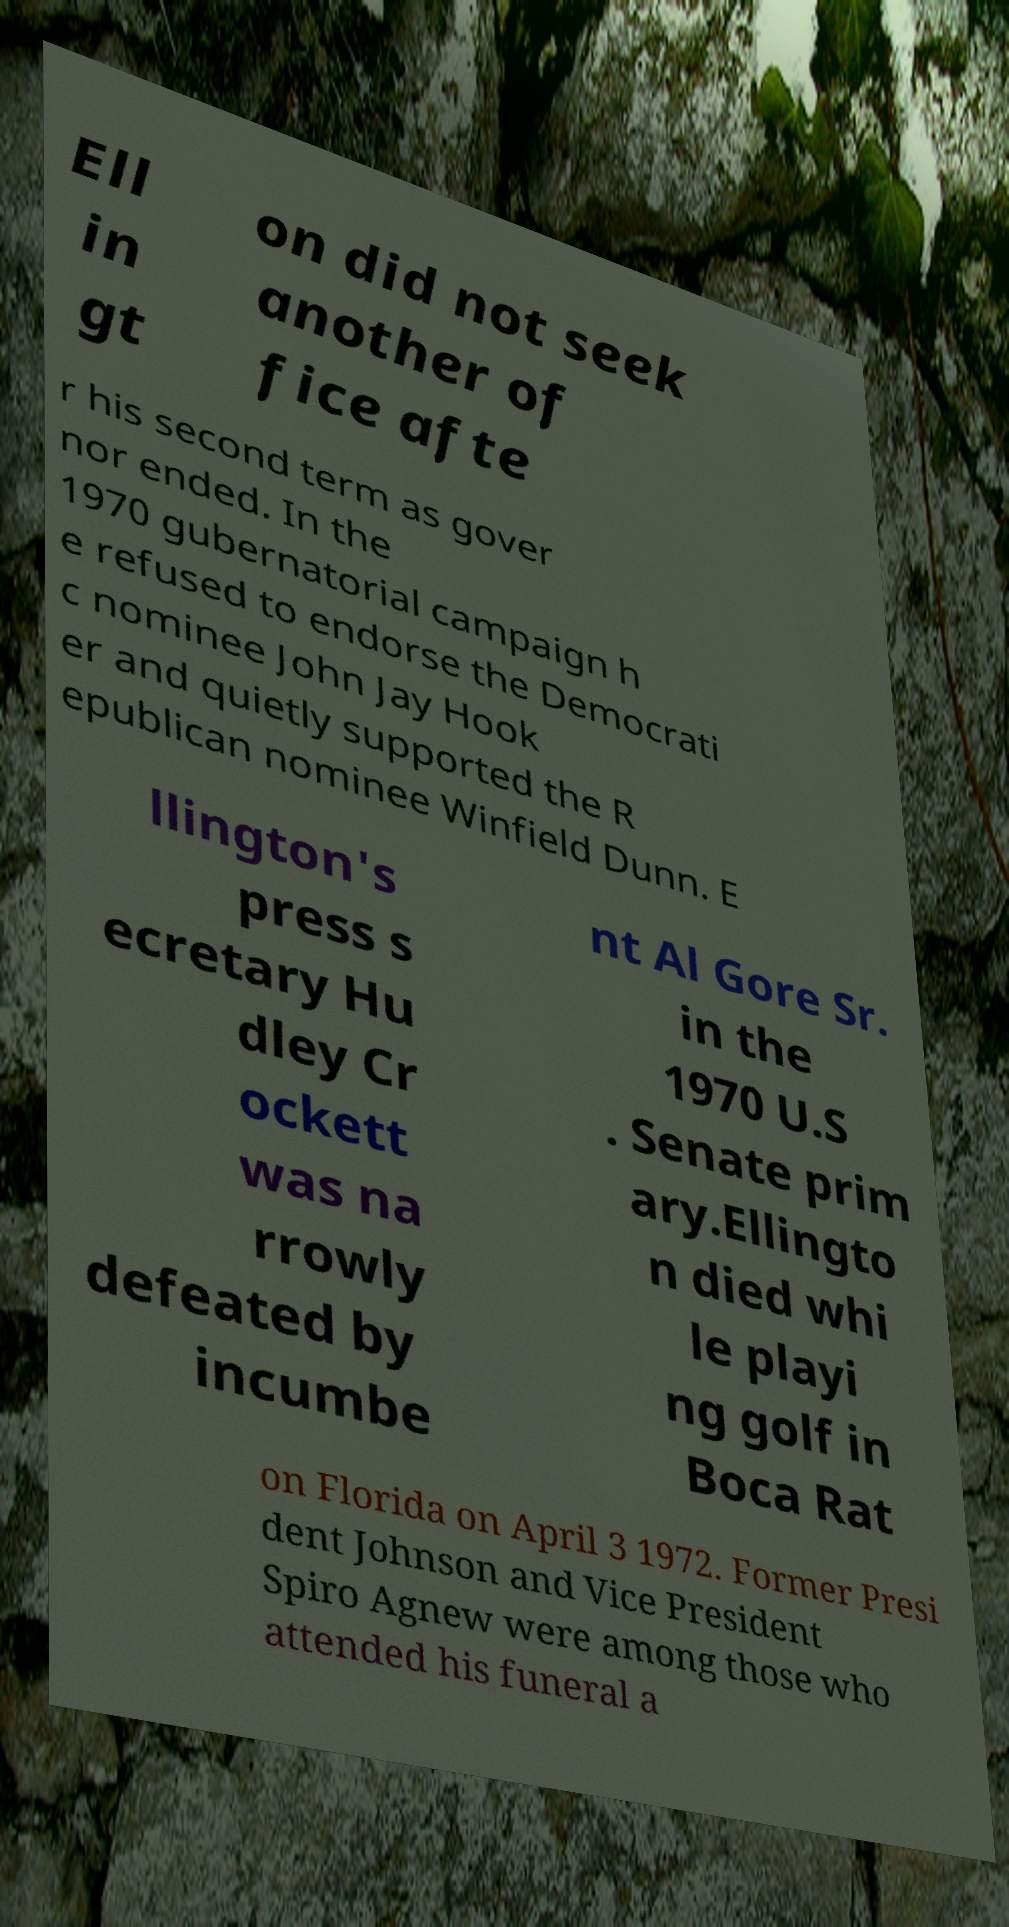Could you assist in decoding the text presented in this image and type it out clearly? Ell in gt on did not seek another of fice afte r his second term as gover nor ended. In the 1970 gubernatorial campaign h e refused to endorse the Democrati c nominee John Jay Hook er and quietly supported the R epublican nominee Winfield Dunn. E llington's press s ecretary Hu dley Cr ockett was na rrowly defeated by incumbe nt Al Gore Sr. in the 1970 U.S . Senate prim ary.Ellingto n died whi le playi ng golf in Boca Rat on Florida on April 3 1972. Former Presi dent Johnson and Vice President Spiro Agnew were among those who attended his funeral a 